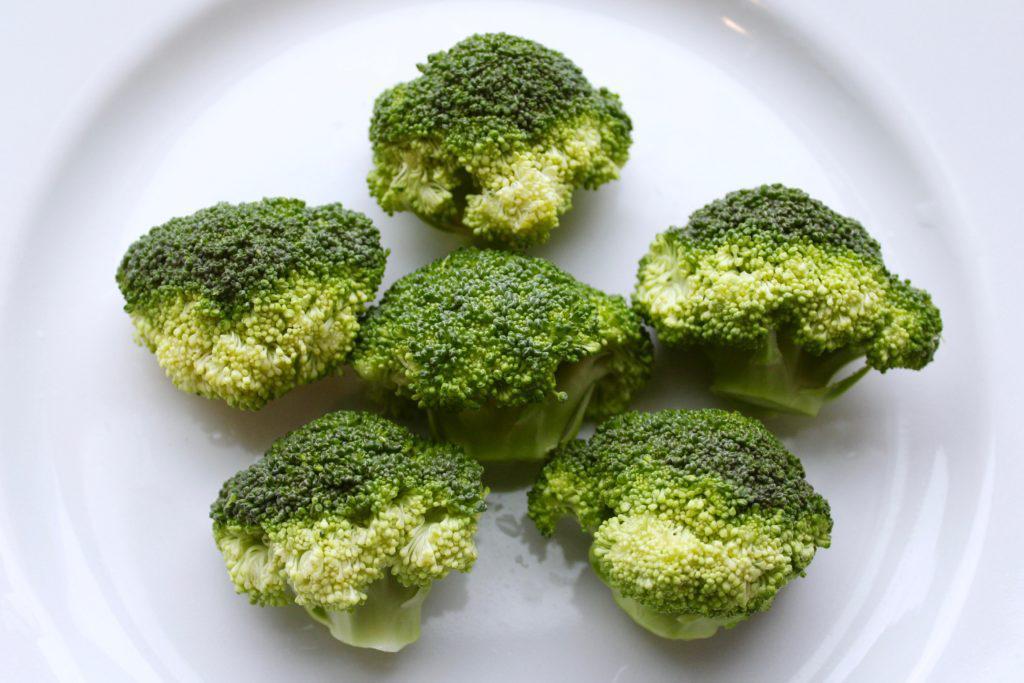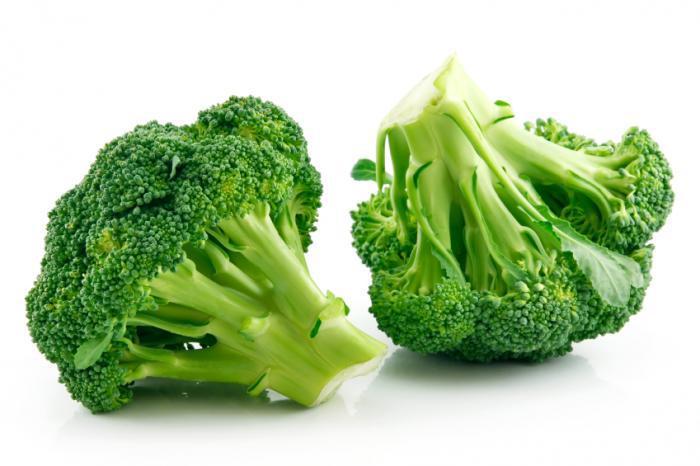The first image is the image on the left, the second image is the image on the right. For the images shown, is this caption "One image shows broccoli on a wooden cutting board." true? Answer yes or no. No. 